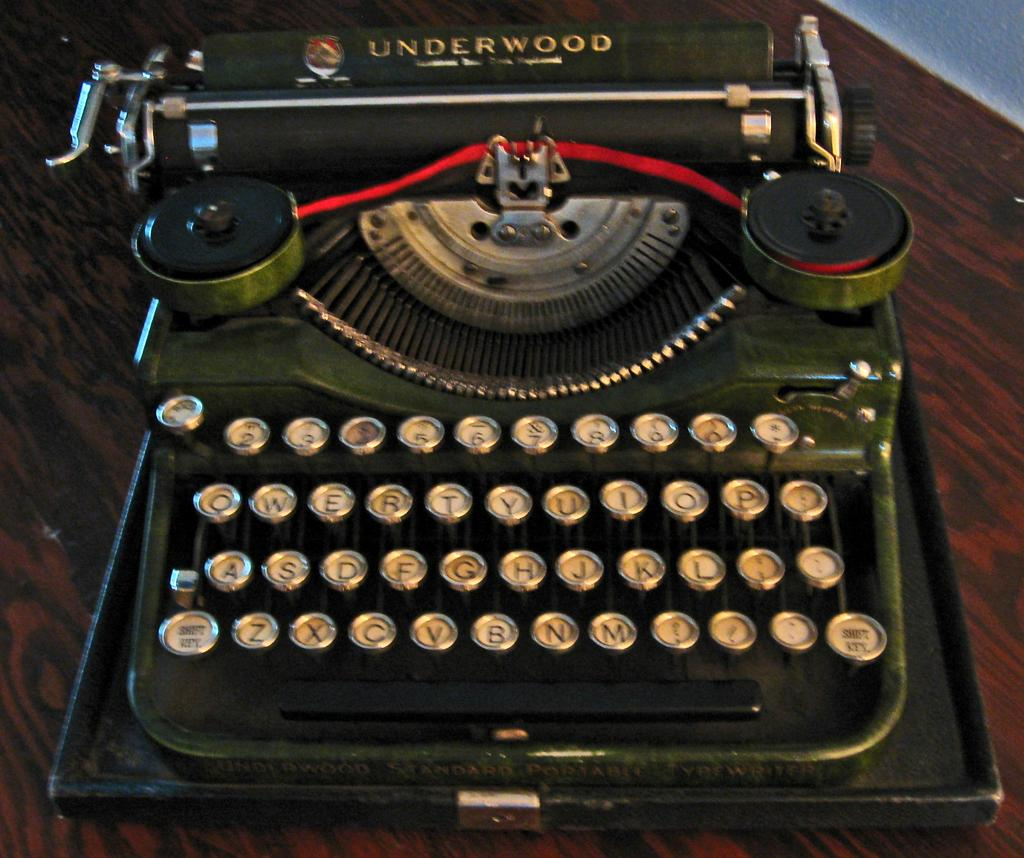Provide a one-sentence caption for the provided image. A old Underwood type writer, the keys look in good condition. 